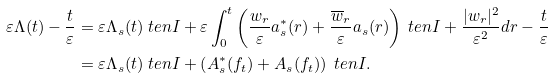<formula> <loc_0><loc_0><loc_500><loc_500>\varepsilon \Lambda ( t ) - \frac { t } { \varepsilon } & = \varepsilon \Lambda _ { s } ( t ) \ t e n I + \varepsilon \int _ { 0 } ^ { t } \left ( \frac { w _ { r } } { \varepsilon } a ^ { * } _ { s } ( r ) + \frac { \overline { w } _ { r } } { \varepsilon } a _ { s } ( r ) \right ) \ t e n I + \frac { | w _ { r } | ^ { 2 } } { \varepsilon ^ { 2 } } d r - \frac { t } { \varepsilon } \\ & = \varepsilon \Lambda _ { s } ( t ) \ t e n I + \left ( A ^ { * } _ { s } ( f _ { t } ) + A _ { s } ( f _ { t } ) \right ) \ t e n I .</formula> 